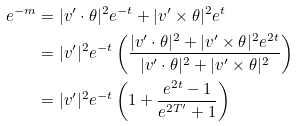Convert formula to latex. <formula><loc_0><loc_0><loc_500><loc_500>e ^ { - m } & = | v ^ { \prime } \cdot \theta | ^ { 2 } e ^ { - t } + | v ^ { \prime } \times \theta | ^ { 2 } e ^ { t } \\ & = | v ^ { \prime } | ^ { 2 } e ^ { - t } \left ( \frac { | v ^ { \prime } \cdot \theta | ^ { 2 } + | v ^ { \prime } \times \theta | ^ { 2 } e ^ { 2 t } } { | v ^ { \prime } \cdot \theta | ^ { 2 } + | v ^ { \prime } \times \theta | ^ { 2 } } \right ) \\ & = | v ^ { \prime } | ^ { 2 } e ^ { - t } \left ( 1 + \frac { e ^ { 2 t } - 1 } { e ^ { 2 T ^ { \prime } } + 1 } \right )</formula> 